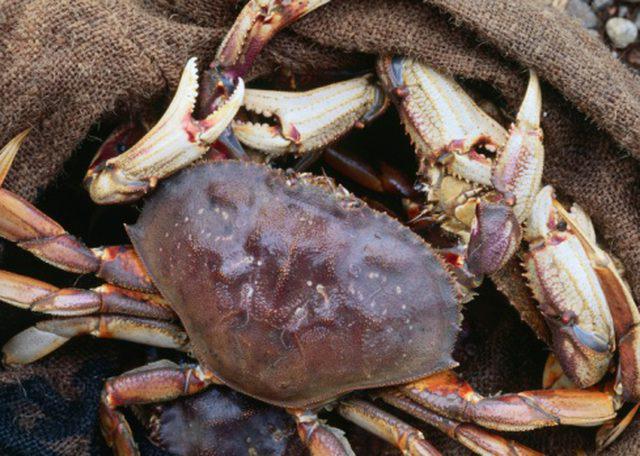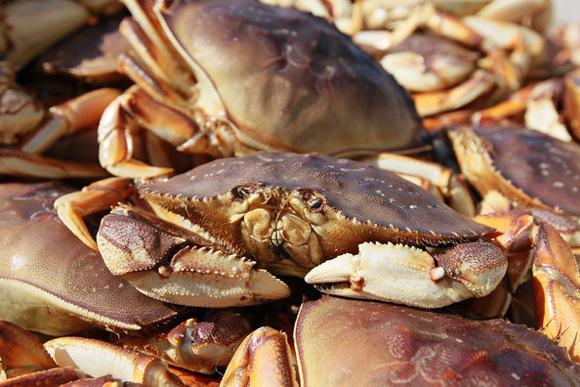The first image is the image on the left, the second image is the image on the right. Examine the images to the left and right. Is the description "The left and right images each show only one crab, and one of the pictured crabs is on a white background and has black-tipped front claws." accurate? Answer yes or no. No. The first image is the image on the left, the second image is the image on the right. Assess this claim about the two images: "The right image contains no more than one crab.". Correct or not? Answer yes or no. No. 